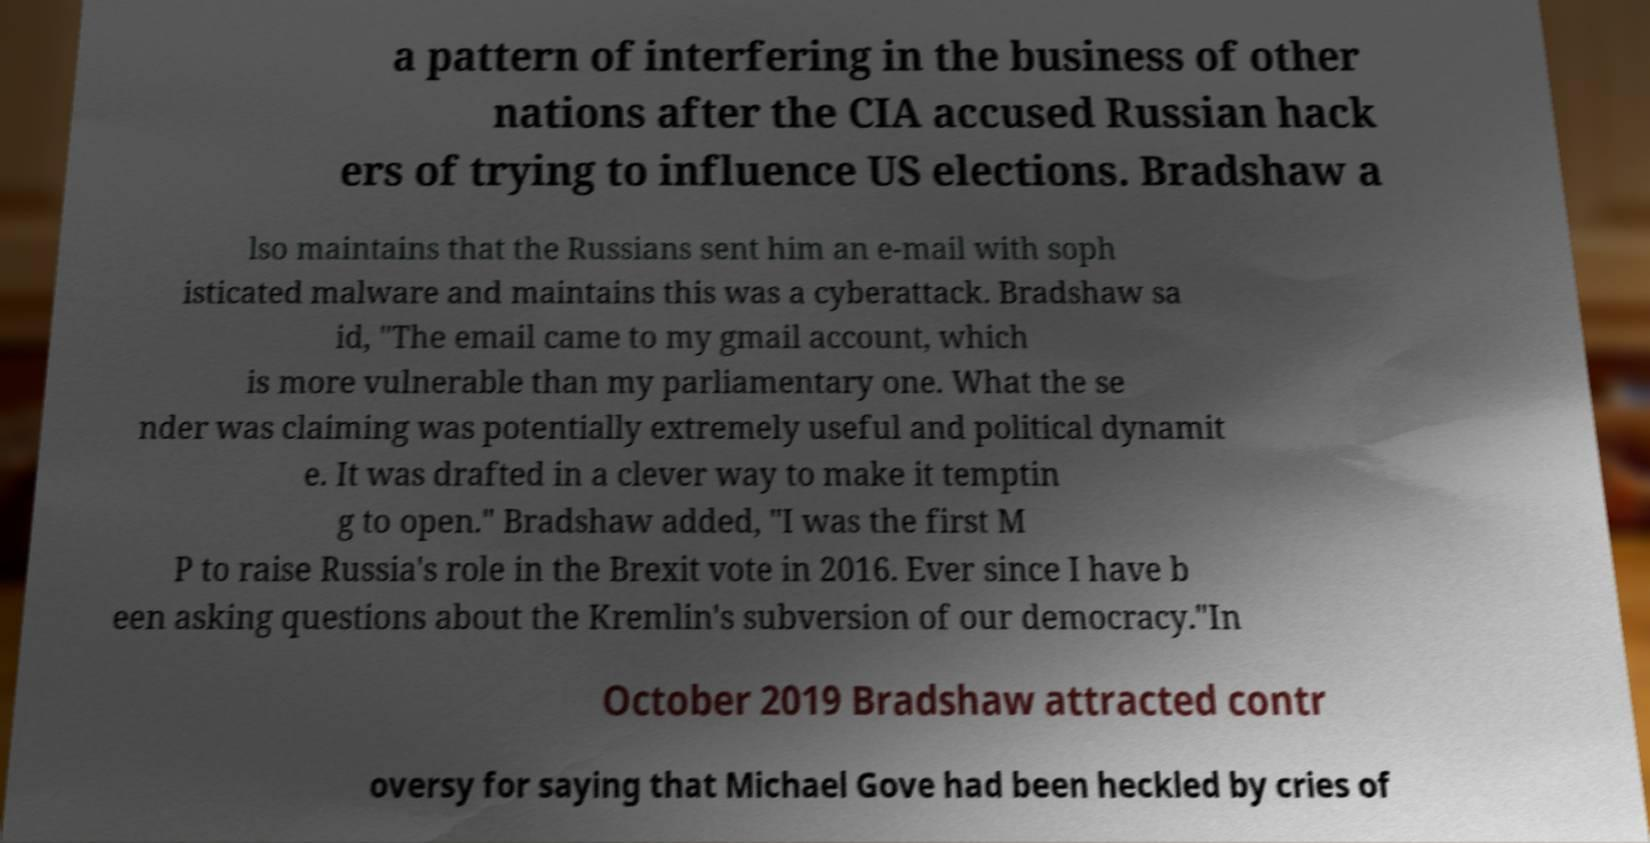Can you read and provide the text displayed in the image?This photo seems to have some interesting text. Can you extract and type it out for me? a pattern of interfering in the business of other nations after the CIA accused Russian hack ers of trying to influence US elections. Bradshaw a lso maintains that the Russians sent him an e-mail with soph isticated malware and maintains this was a cyberattack. Bradshaw sa id, "The email came to my gmail account, which is more vulnerable than my parliamentary one. What the se nder was claiming was potentially extremely useful and political dynamit e. It was drafted in a clever way to make it temptin g to open." Bradshaw added, "I was the first M P to raise Russia's role in the Brexit vote in 2016. Ever since I have b een asking questions about the Kremlin's subversion of our democracy."In October 2019 Bradshaw attracted contr oversy for saying that Michael Gove had been heckled by cries of 